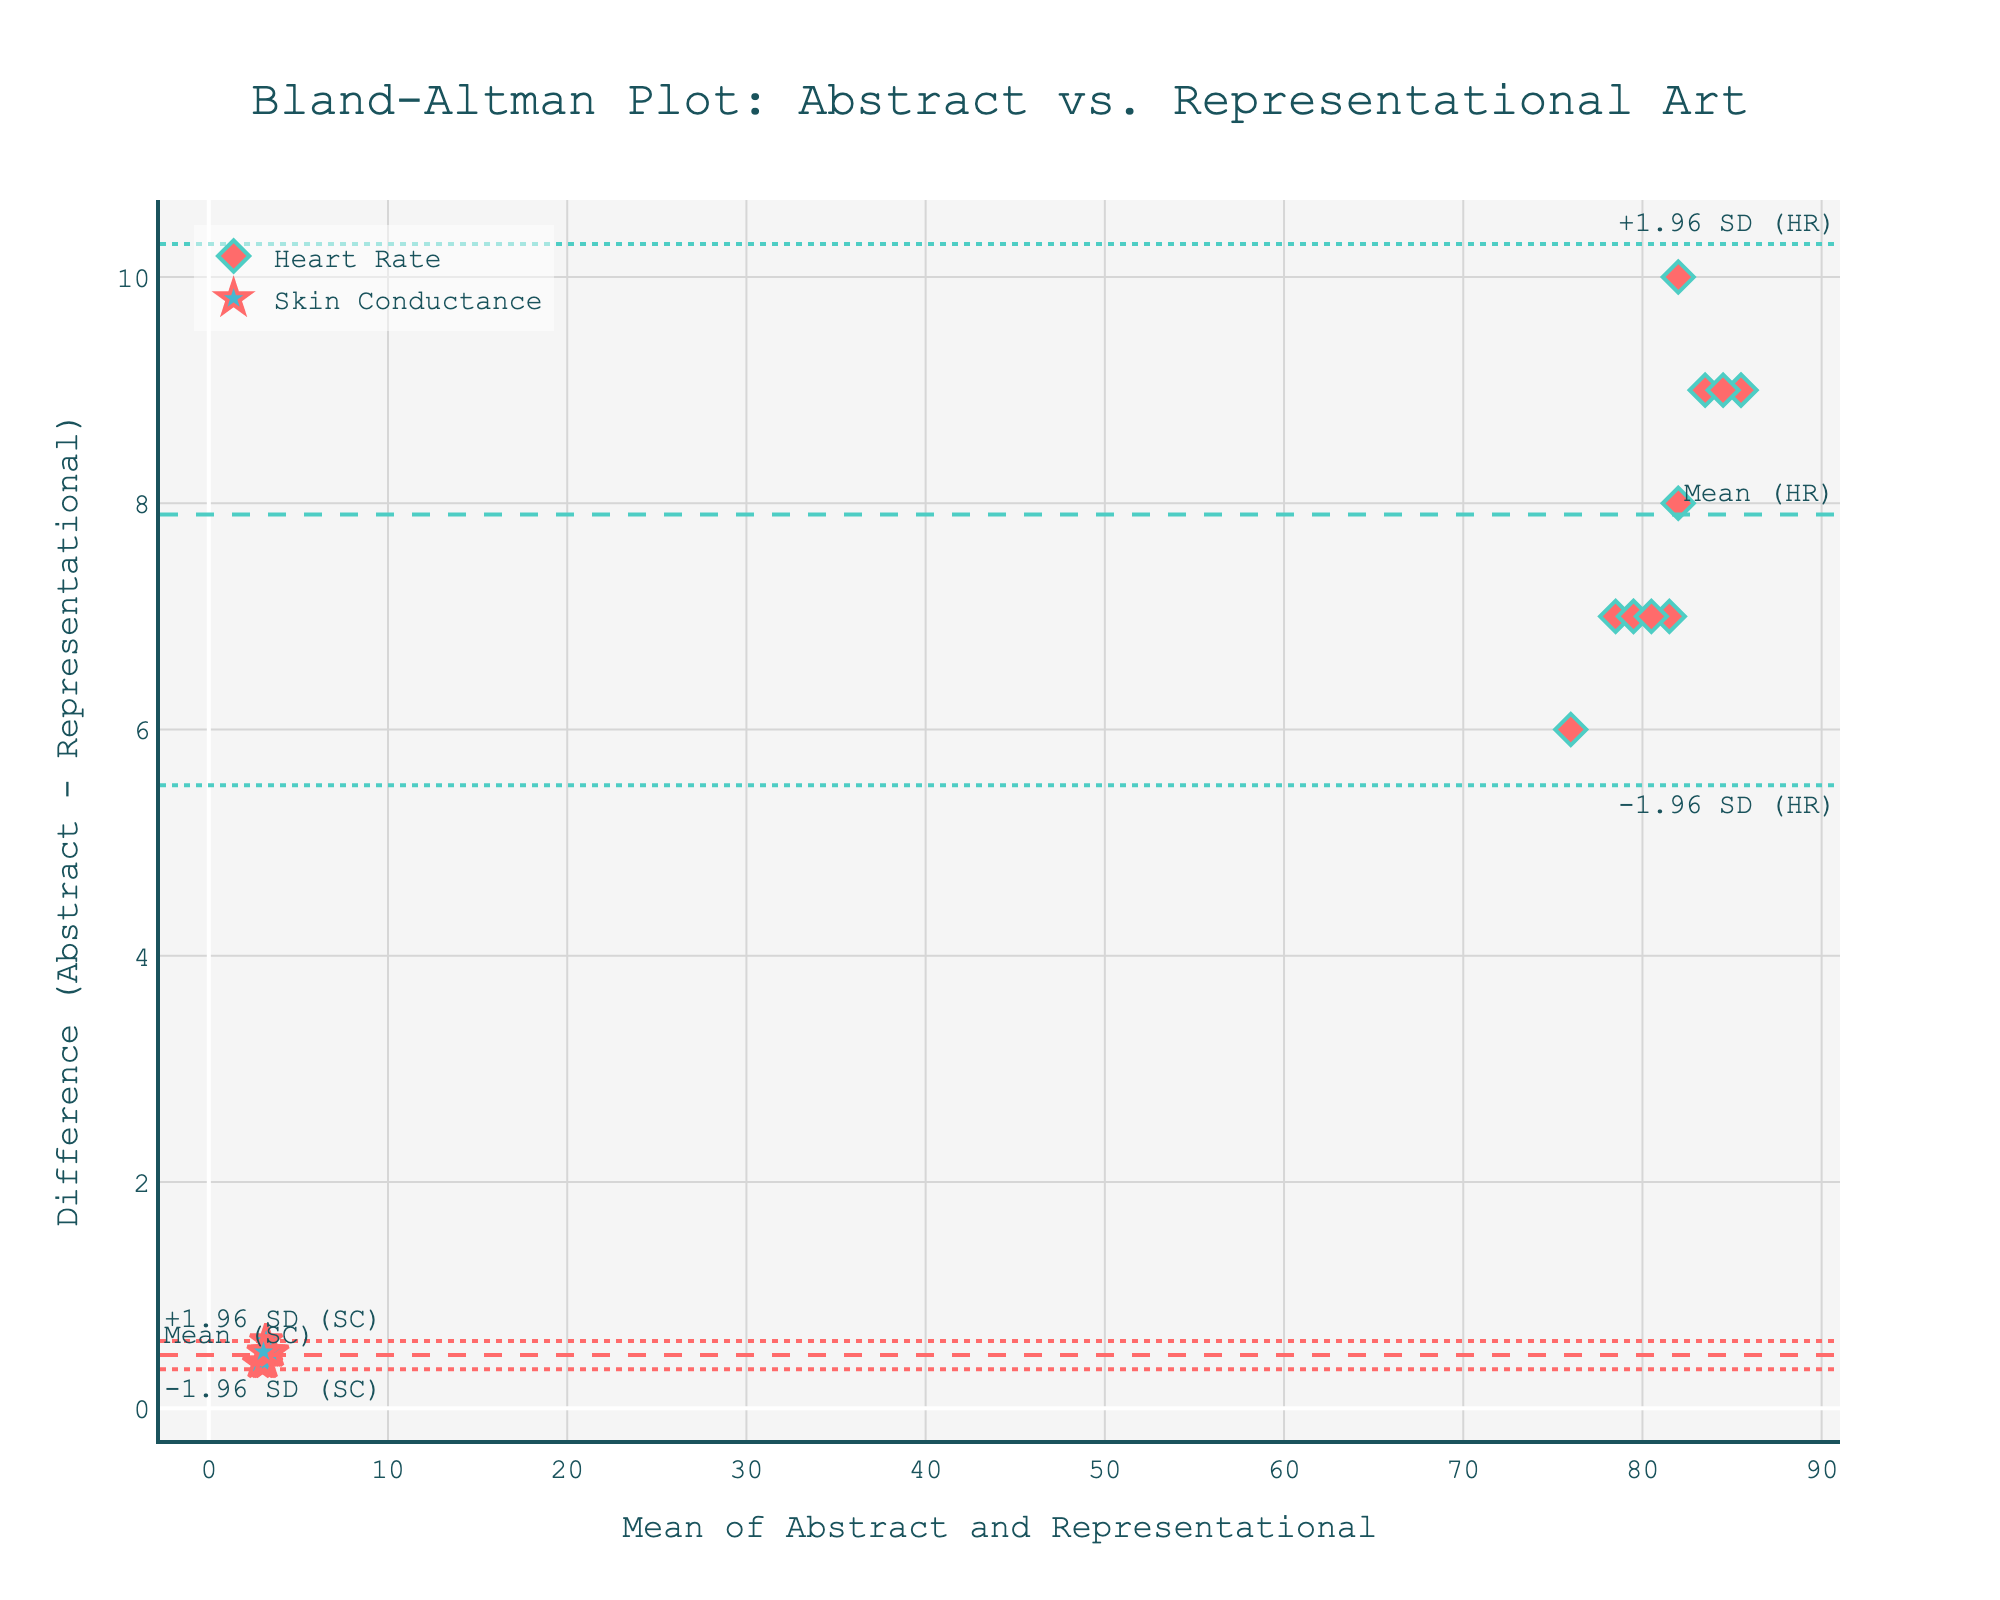What's the title of the figure? The title is displayed at the top of the figure in a prominent and large font.
Answer: Bland-Altman Plot: Abstract vs. Representational Art How many data points represent heart rate measurements? Count the number of diamond markers on the plot, as they represent heart rate measurements. There are 10 diamond markers.
Answer: 10 How is the skin conductance data visually represented? Note the star-shaped markers on the plot which indicate skin conductance data points.
Answer: Star markers What is the mean difference of heart rate between abstract and representational art? Look for the dashed horizontal line labeled "Mean (HR)" and check its position on the Y-axis.
Answer: Approximately 7 bpm Which parameter shows a higher variance in the differences, heart rate or skin conductance? Compare the spread of the differences around their respective means by observing the spacing of the dotted lines representing ±1.96 SD from the mean. Heart rate has a wider spread.
Answer: Heart rate What is the value of +1.96 SD (SC) on the plot? Identify the lined labeled "+1.96 SD (SC)" and read its Y-axis value.
Answer: Approximately 0.75 μS For which type of art is the average heart rate higher, abstract or representational? The mean difference line (Mean (HR)) lies above zero, indicating the average heart rate for abstract art is higher.
Answer: Abstract art Compare the heart rate and skin conductance mean differences. Which is higher? Examine the positions of the dashed lines labeled "Mean (HR)" and "Mean (SC)" and compare their Y-values.
Answer: Heart rate mean difference Which subject had the largest difference in heart rate between the two art styles? Check the highest diamond marker on the plot to see the corresponding mean value along the X-axis; use this to cross-reference subject data.
Answer: Salvador Dali What does a data point below the zero on the Y-axis indicate? It represents that the measurement (heart rate or skin conductance) was lower for abstract art compared to representational art for that particular subject.
Answer: Lower measurement for abstract art 